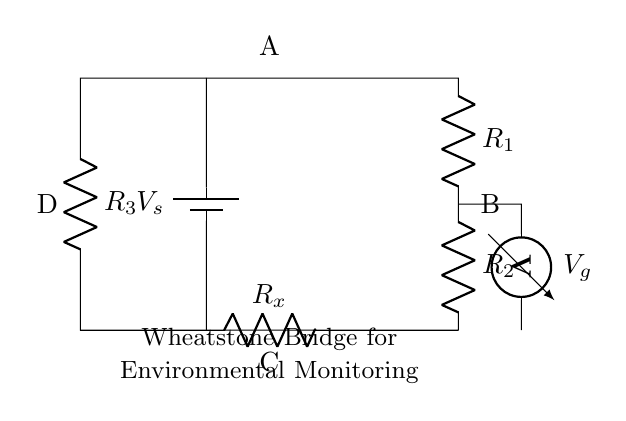What type of bridge is this circuit? This circuit is a Wheatstone Bridge, which is used for measuring unknown resistances by balancing two legs of a bridge circuit.
Answer: Wheatstone Bridge What are the values of the resistors in the circuit? The circuit lists resistors as R1, R2, R3, and Rx, but specific numerical values aren't indicated in the diagram. The answer is inferred as they are placeholders.
Answer: R1, R2, R3, Rx What is the function of the voltmeter in this circuit? The voltmeter measures the voltage difference between two points in the circuit (between points B and D). It helps determine if the bridge is balanced.
Answer: Measure voltage What voltage source is shown in this circuit? The circuit includes a voltage source labeled as Vs, implying it provides the necessary potential difference for the Wheatstone Bridge operation.
Answer: Vs What is measured across the points B and D? The measurement across points B and D is the voltage Vg, which indicates the potential difference that signals if the bridge is in balance.
Answer: Vg In what application is this type of circuit typically used? The Wheatstone Bridge is commonly used in environmental monitoring sensors to measure resistances that can vary with environmental conditions (like temperature changes).
Answer: Environmental monitoring 